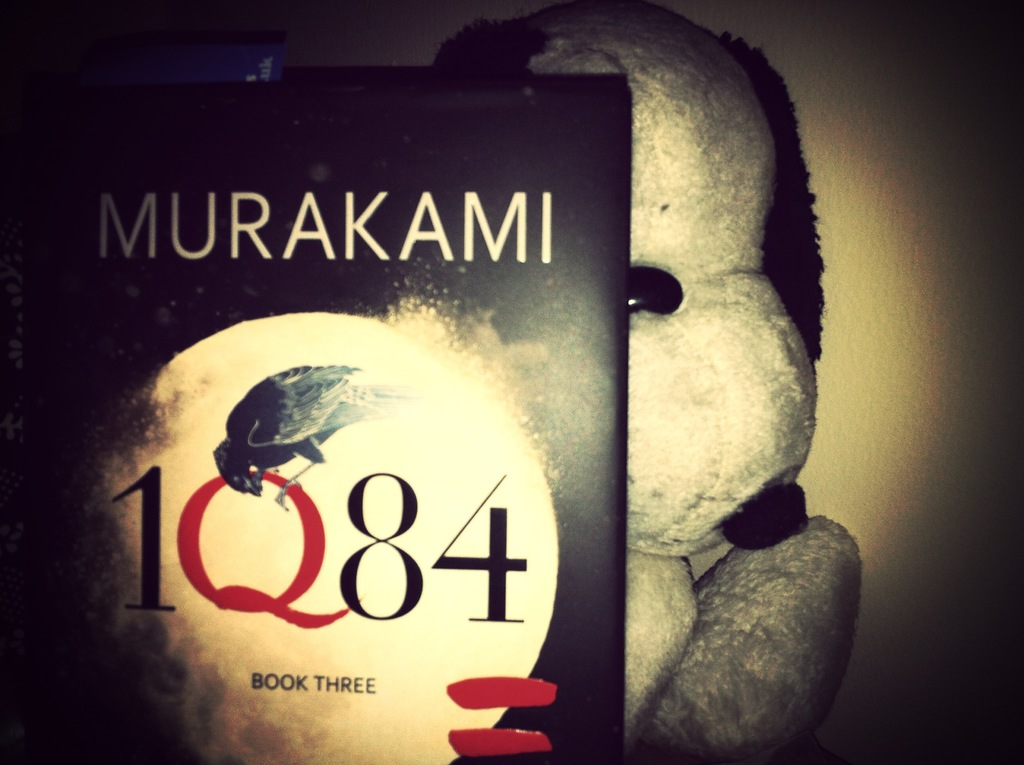Can you describe the emotional impact or atmosphere conveyed by the combination of the book and the plush toy in the image? This composition evokes a sense of nostalgia and loneliness. The plush toy, often a symbol of comfort and childhood, alongside a sophisticated novel about parallel existences, contrasts innocence with the complexity of adult life. How might this contrast change a viewer's perception of the book? The juxtaposition might suggest that despite the novel's deep and possibly dark themes, there's an inherent softness or approachability, making it more inviting to readers who might initially be intimidated by its depth. 